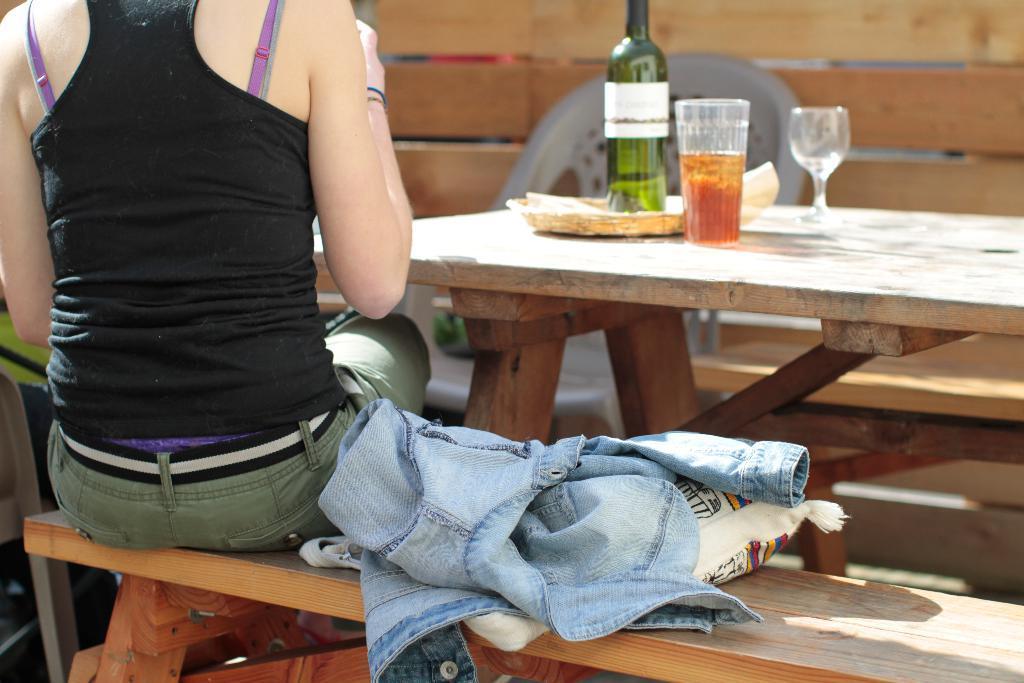Please provide a concise description of this image. In this picture, we see woman in black t-shirt and green jeans is sitting on bench. On bench, we see blue jacket and white bag. In front of her, we see a table on which green bottle, plate and glass containing cold drink are placed on it and behind that, we see a chair and wooden fence. 